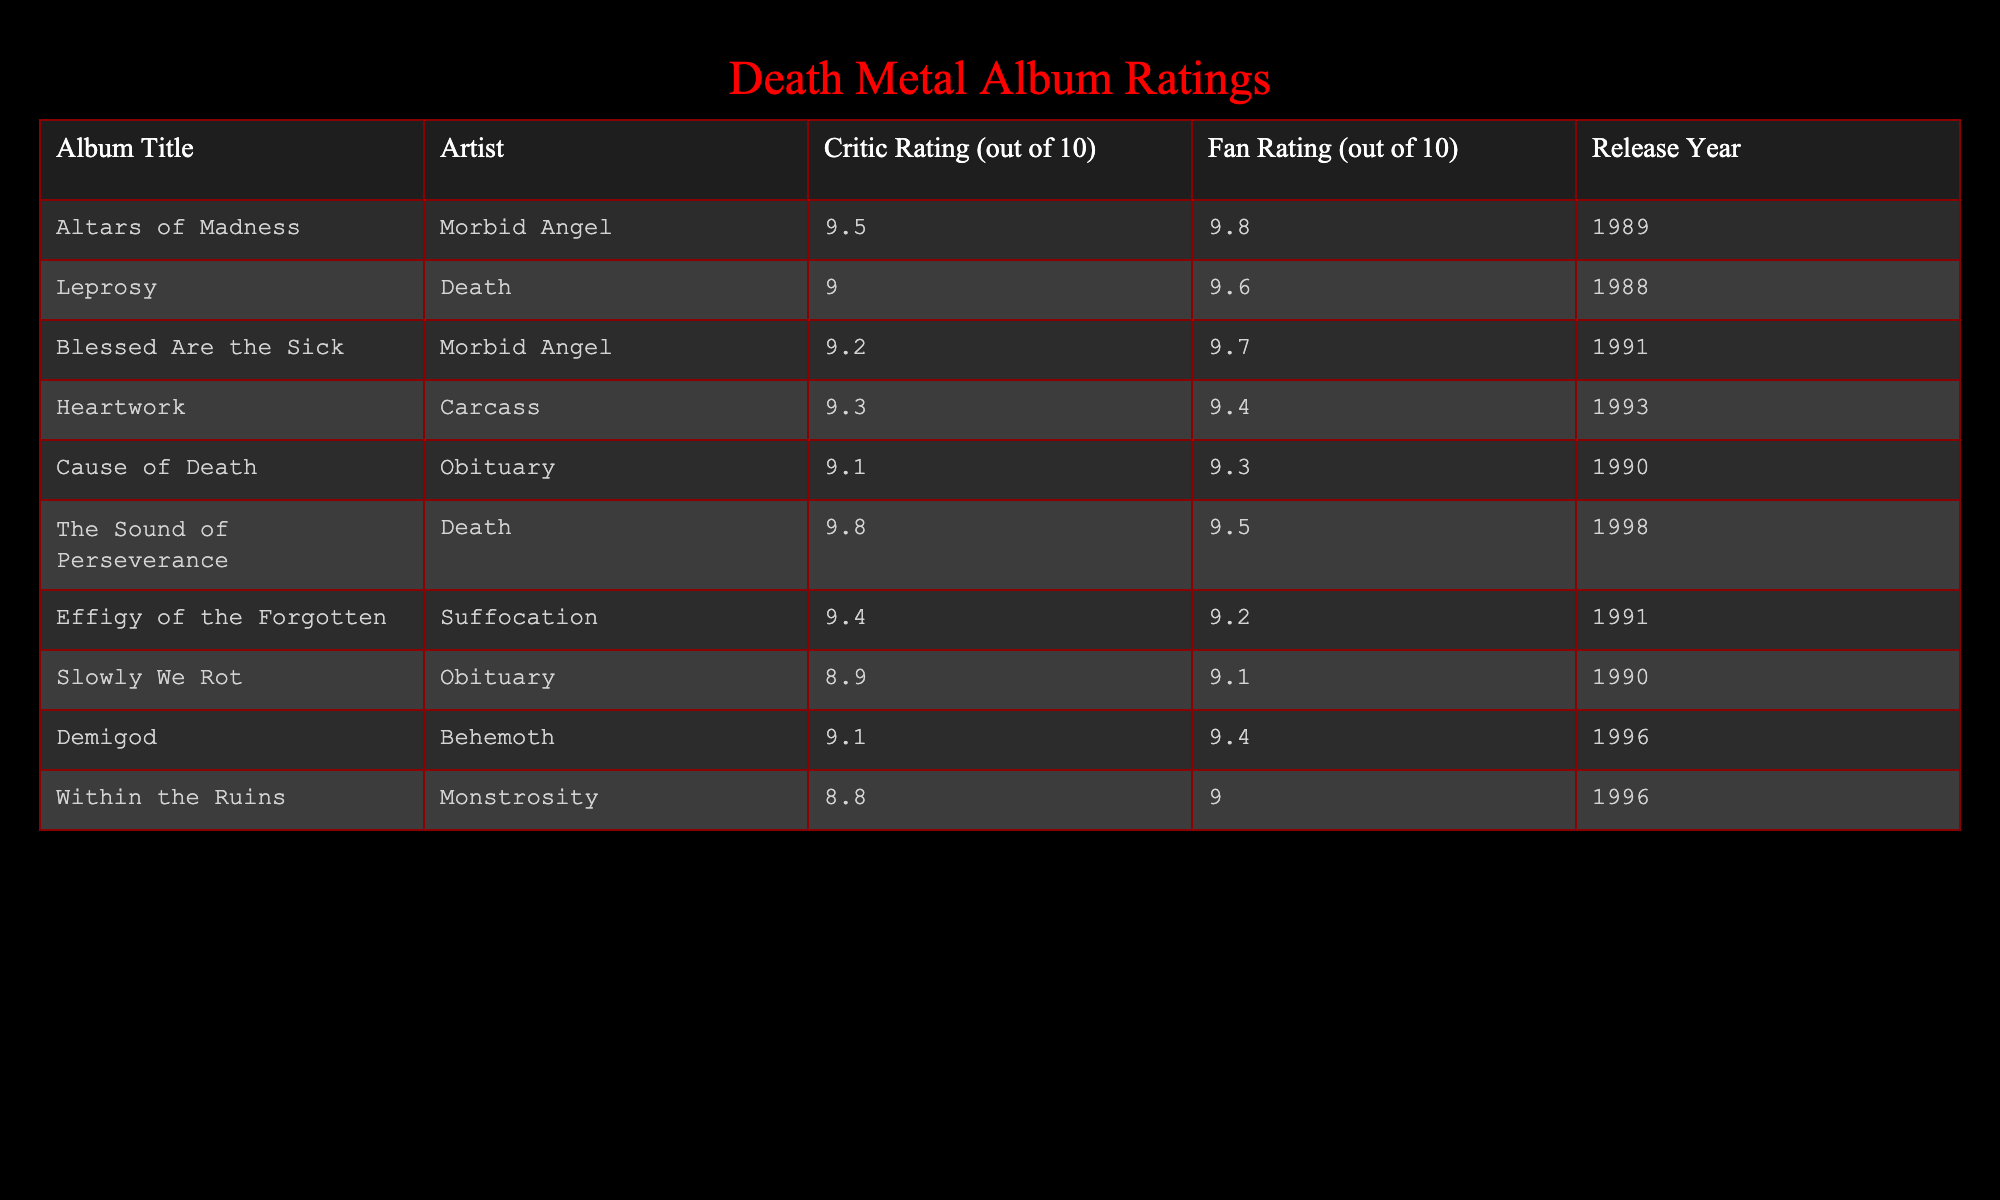What is the highest critic rating in the table? The table lists the critic ratings for various albums. The highest critic rating is found by scanning the "Critic Rating" column to identify the maximum value, which is 9.8 for "The Sound of Perseverance" by Death.
Answer: 9.8 Which album has the lowest fan rating? To find the lowest fan rating, I look at the "Fan Rating" column and identify the minimum value, which is 8.8 for "Within the Ruins" by Monstrosity.
Answer: 8.8 How many albums have critic ratings above 9.0? By examining the "Critic Rating" column, I count the number of albums where the rating is greater than 9.0. The albums that meet this criterion are "Altars of Madness," "Leprosy," "Blessed Are the Sick," "Heartwork," "The Sound of Perseverance," "Effigy of the Forgotten," which totals to 6 albums.
Answer: 6 What is the average fan rating for the albums listed? To calculate the average fan rating, I sum the fan ratings: (9.8 + 9.6 + 9.7 + 9.4 + 9.3 + 9.5 + 9.2 + 9.1 + 9.4 + 9.0) = 94.0. Then, I divide by the number of albums (10) to find the average: 94.0 / 10 = 9.4.
Answer: 9.4 Is "Cause of Death" rated higher by critics than fans? By checking the ratings for "Cause of Death," I see the critic rating is 9.1 while the fan rating is 9.3. Since 9.1 is less than 9.3, the statement is false.
Answer: No How many albums were released in the 1990s with a critic rating of 9.0 or higher? Reviewing the "Release Year" and "Critic Rating" columns, I find the following albums from the 1990s with ratings of 9.0 or higher: "Cause of Death," "Heartwork," "Blessed Are the Sick," "Effigy of the Forgotten," and "The Sound of Perseverance." This gives a total of 5 albums.
Answer: 5 Which artist has the highest rated album according to critics? Looking through the "Artist" column along with the corresponding "Critic Rating," I see that "Death" has the highest-rated album, "The Sound of Perseverance," with a critic rating of 9.8.
Answer: Death What is the difference between the highest and lowest fan ratings in the dataset? I determine the highest fan rating in the table, which is 9.8 (for "Altars of Madness"), and the lowest fan rating, which is 8.8 (for "Within the Ruins"). The difference is calculated as 9.8 - 8.8 = 1.0.
Answer: 1.0 